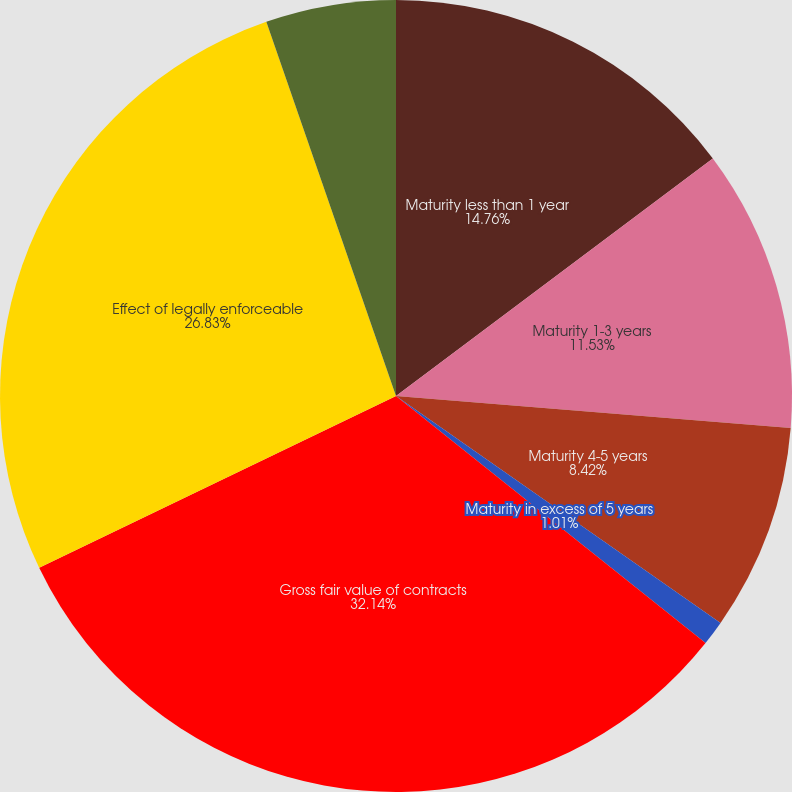Convert chart. <chart><loc_0><loc_0><loc_500><loc_500><pie_chart><fcel>Maturity less than 1 year<fcel>Maturity 1-3 years<fcel>Maturity 4-5 years<fcel>Maturity in excess of 5 years<fcel>Gross fair value of contracts<fcel>Effect of legally enforceable<fcel>Net fair value of contracts<nl><fcel>14.76%<fcel>11.53%<fcel>8.42%<fcel>1.01%<fcel>32.14%<fcel>26.83%<fcel>5.31%<nl></chart> 